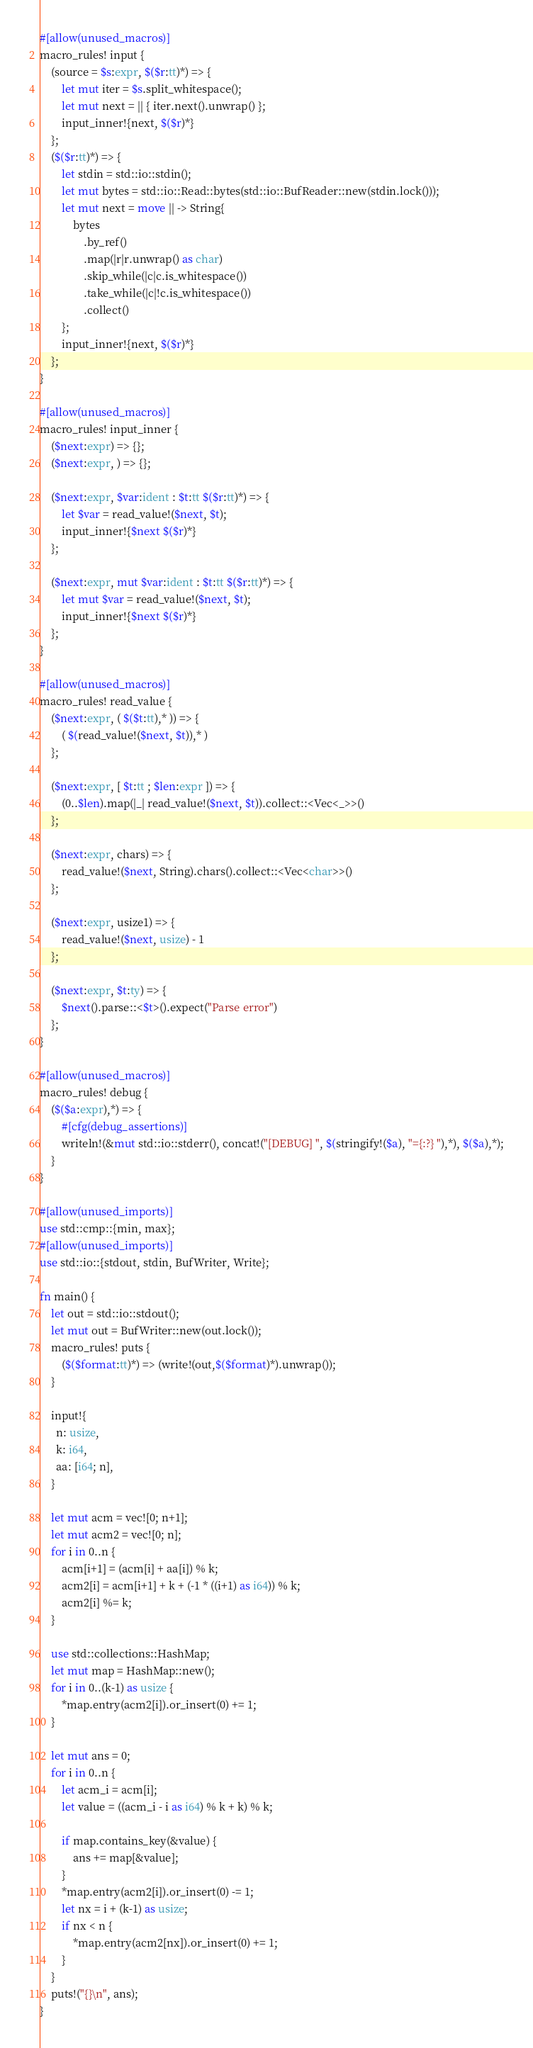Convert code to text. <code><loc_0><loc_0><loc_500><loc_500><_Rust_>#[allow(unused_macros)]
macro_rules! input {
    (source = $s:expr, $($r:tt)*) => {
        let mut iter = $s.split_whitespace();
        let mut next = || { iter.next().unwrap() };
        input_inner!{next, $($r)*}
    };
    ($($r:tt)*) => {
        let stdin = std::io::stdin();
        let mut bytes = std::io::Read::bytes(std::io::BufReader::new(stdin.lock()));
        let mut next = move || -> String{
            bytes
                .by_ref()
                .map(|r|r.unwrap() as char)
                .skip_while(|c|c.is_whitespace())
                .take_while(|c|!c.is_whitespace())
                .collect()
        };
        input_inner!{next, $($r)*}
    };
}

#[allow(unused_macros)]
macro_rules! input_inner {
    ($next:expr) => {};
    ($next:expr, ) => {};

    ($next:expr, $var:ident : $t:tt $($r:tt)*) => {
        let $var = read_value!($next, $t);
        input_inner!{$next $($r)*}
    };

    ($next:expr, mut $var:ident : $t:tt $($r:tt)*) => {
        let mut $var = read_value!($next, $t);
        input_inner!{$next $($r)*}
    };
}

#[allow(unused_macros)]
macro_rules! read_value {
    ($next:expr, ( $($t:tt),* )) => {
        ( $(read_value!($next, $t)),* )
    };

    ($next:expr, [ $t:tt ; $len:expr ]) => {
        (0..$len).map(|_| read_value!($next, $t)).collect::<Vec<_>>()
    };

    ($next:expr, chars) => {
        read_value!($next, String).chars().collect::<Vec<char>>()
    };

    ($next:expr, usize1) => {
        read_value!($next, usize) - 1
    };

    ($next:expr, $t:ty) => {
        $next().parse::<$t>().expect("Parse error")
    };
}

#[allow(unused_macros)]
macro_rules! debug {
    ($($a:expr),*) => {
        #[cfg(debug_assertions)]
        writeln!(&mut std::io::stderr(), concat!("[DEBUG] ", $(stringify!($a), "={:?} "),*), $($a),*);
    }
}

#[allow(unused_imports)]
use std::cmp::{min, max};
#[allow(unused_imports)]
use std::io::{stdout, stdin, BufWriter, Write};

fn main() {
    let out = std::io::stdout();
    let mut out = BufWriter::new(out.lock());
    macro_rules! puts {
        ($($format:tt)*) => (write!(out,$($format)*).unwrap());
    }

    input!{
      n: usize,
      k: i64,
      aa: [i64; n],
    }

    let mut acm = vec![0; n+1];
    let mut acm2 = vec![0; n];
    for i in 0..n {
        acm[i+1] = (acm[i] + aa[i]) % k;
        acm2[i] = acm[i+1] + k + (-1 * ((i+1) as i64)) % k;
        acm2[i] %= k;
    }

    use std::collections::HashMap;
    let mut map = HashMap::new();
    for i in 0..(k-1) as usize {
        *map.entry(acm2[i]).or_insert(0) += 1;
    }

    let mut ans = 0;
    for i in 0..n {
        let acm_i = acm[i];
        let value = ((acm_i - i as i64) % k + k) % k;

        if map.contains_key(&value) {
            ans += map[&value];
        }
        *map.entry(acm2[i]).or_insert(0) -= 1;
        let nx = i + (k-1) as usize;
        if nx < n {
            *map.entry(acm2[nx]).or_insert(0) += 1;
        }
    }
    puts!("{}\n", ans);
}
</code> 